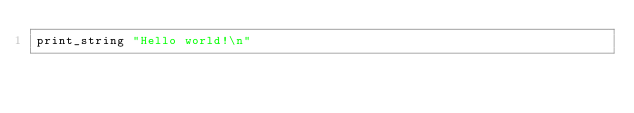Convert code to text. <code><loc_0><loc_0><loc_500><loc_500><_OCaml_>print_string "Hello world!\n"</code> 